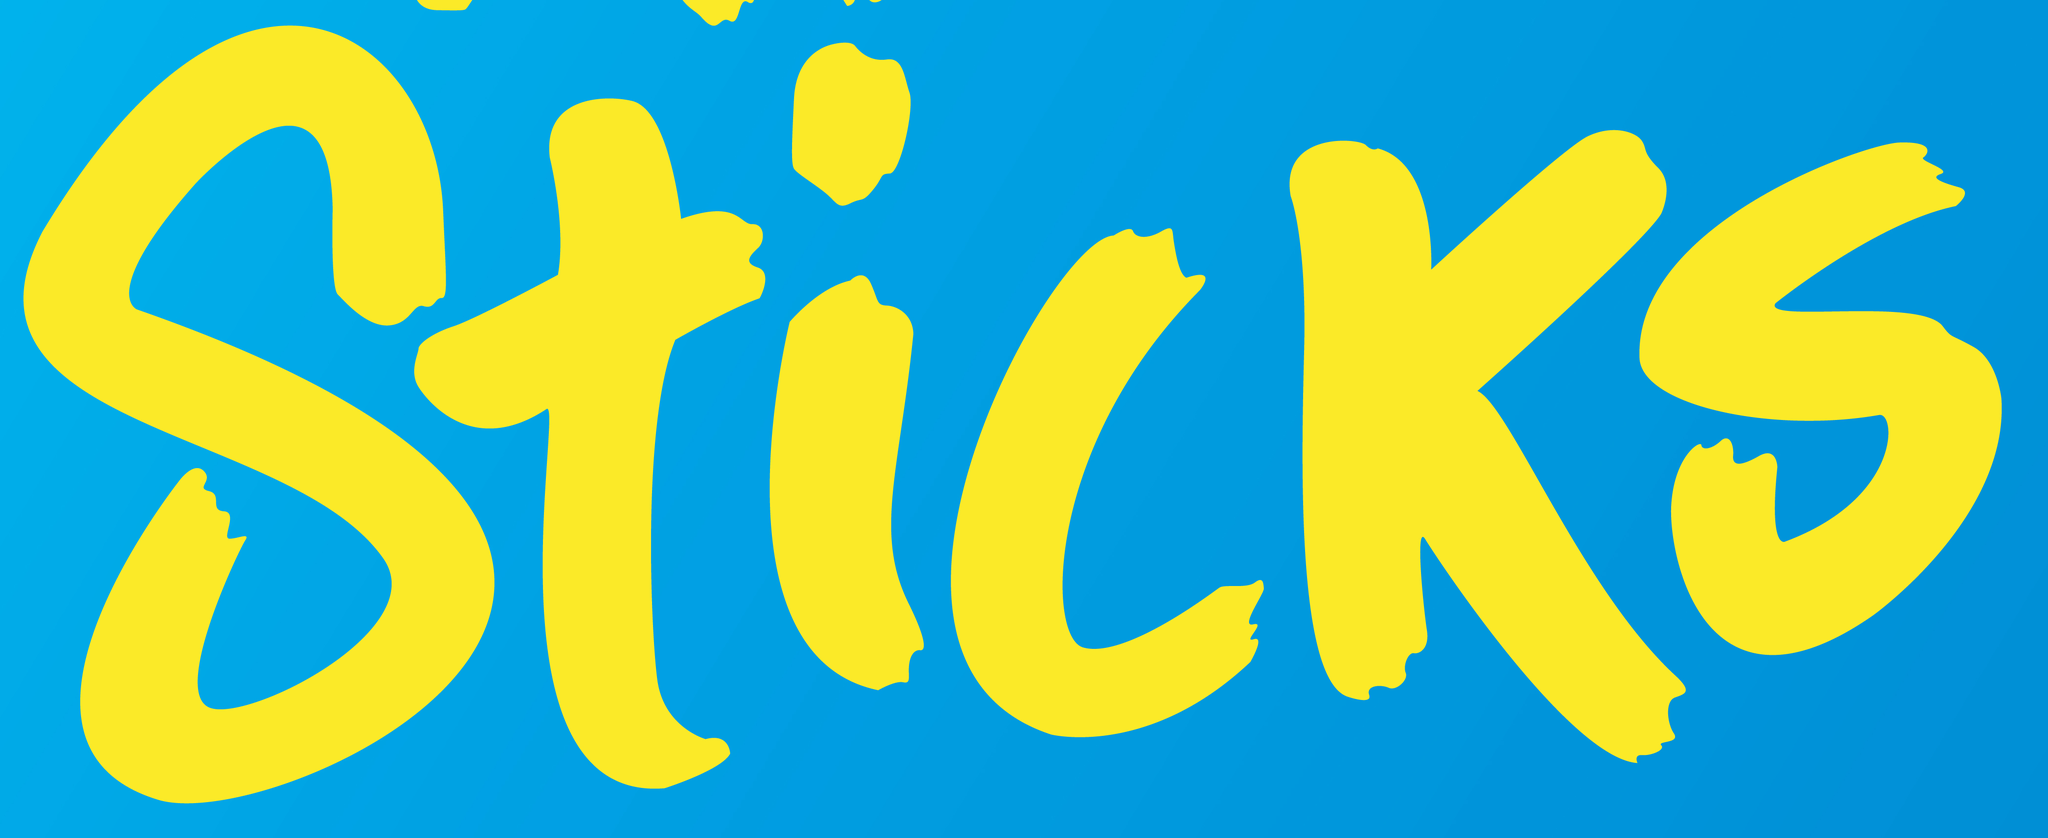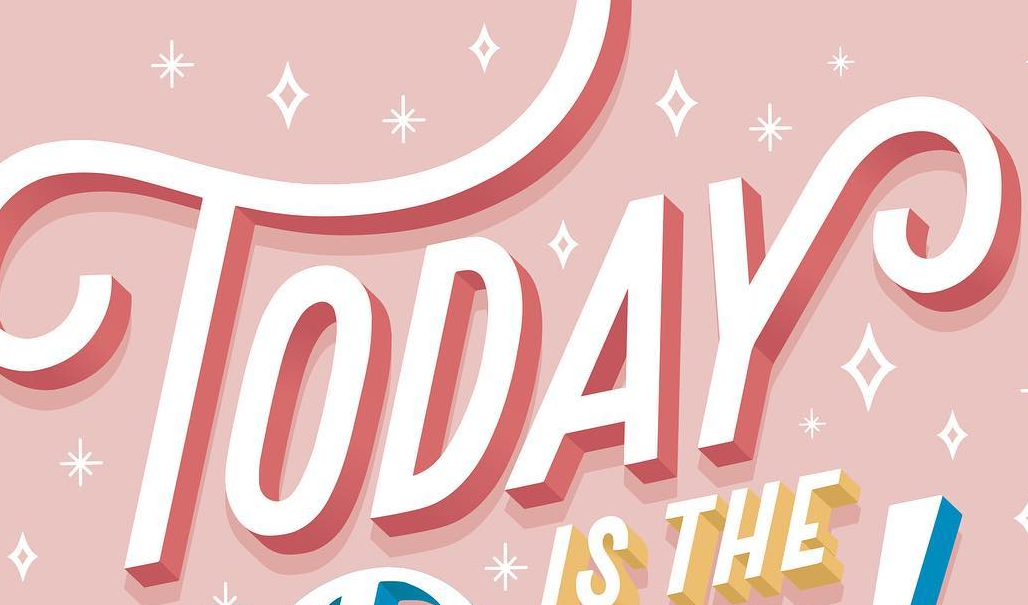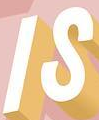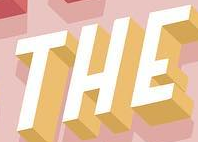What words are shown in these images in order, separated by a semicolon? Sticks; TODAY; IS; THE 